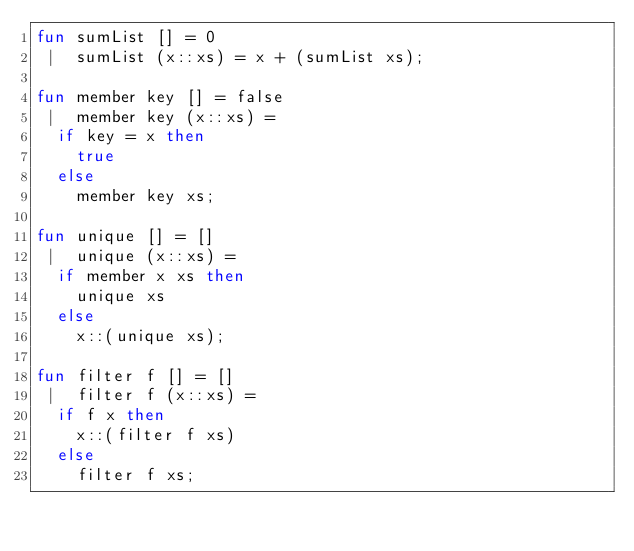<code> <loc_0><loc_0><loc_500><loc_500><_SML_>fun sumList [] = 0
 |  sumList (x::xs) = x + (sumList xs);

fun member key [] = false
 |  member key (x::xs) = 
  if key = x then
    true
  else
    member key xs;

fun unique [] = []
 |  unique (x::xs) = 
  if member x xs then
    unique xs
  else
    x::(unique xs);
  
fun filter f [] = []
 |  filter f (x::xs) =
  if f x then
    x::(filter f xs)
  else
    filter f xs;   
</code> 